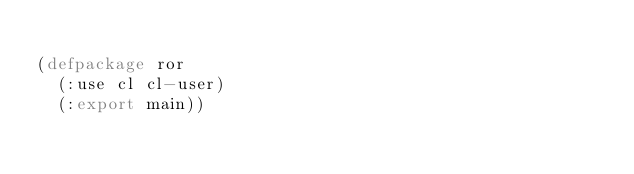<code> <loc_0><loc_0><loc_500><loc_500><_Lisp_>
(defpackage ror
  (:use cl cl-user)
  (:export main))

</code> 